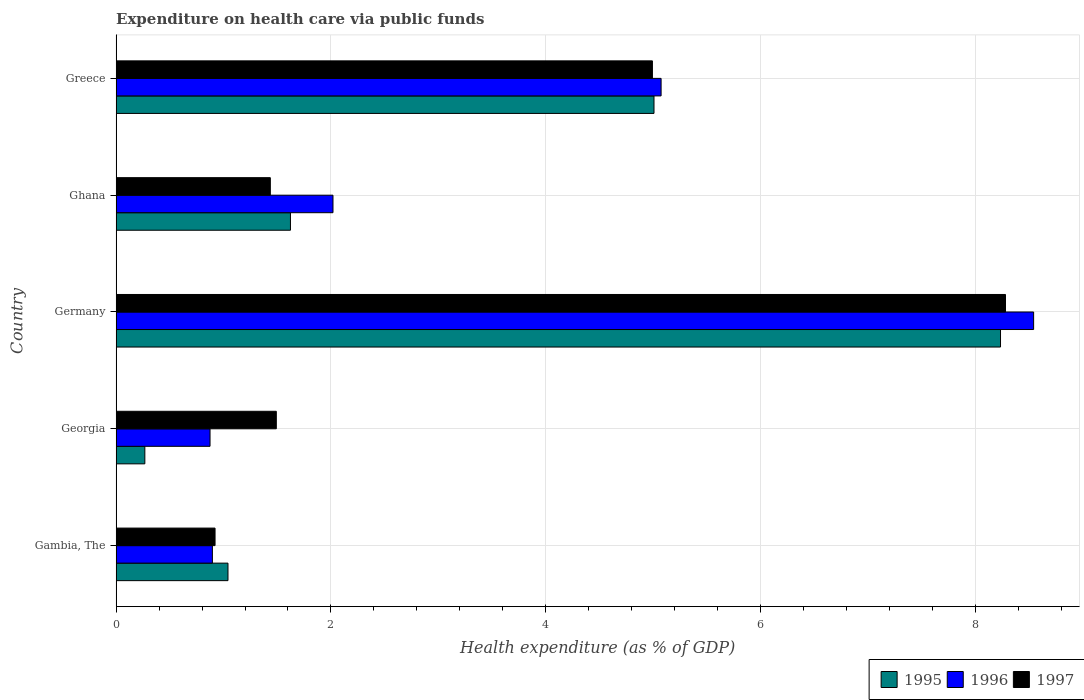How many groups of bars are there?
Your answer should be compact. 5. Are the number of bars per tick equal to the number of legend labels?
Provide a succinct answer. Yes. Are the number of bars on each tick of the Y-axis equal?
Provide a short and direct response. Yes. How many bars are there on the 3rd tick from the bottom?
Keep it short and to the point. 3. What is the label of the 5th group of bars from the top?
Offer a very short reply. Gambia, The. What is the expenditure made on health care in 1995 in Georgia?
Keep it short and to the point. 0.27. Across all countries, what is the maximum expenditure made on health care in 1995?
Offer a very short reply. 8.23. Across all countries, what is the minimum expenditure made on health care in 1996?
Your response must be concise. 0.87. In which country was the expenditure made on health care in 1995 maximum?
Offer a terse response. Germany. In which country was the expenditure made on health care in 1996 minimum?
Keep it short and to the point. Georgia. What is the total expenditure made on health care in 1995 in the graph?
Your answer should be compact. 16.17. What is the difference between the expenditure made on health care in 1995 in Gambia, The and that in Georgia?
Give a very brief answer. 0.77. What is the difference between the expenditure made on health care in 1995 in Greece and the expenditure made on health care in 1996 in Germany?
Give a very brief answer. -3.53. What is the average expenditure made on health care in 1997 per country?
Offer a terse response. 3.42. What is the difference between the expenditure made on health care in 1995 and expenditure made on health care in 1997 in Germany?
Ensure brevity in your answer.  -0.05. What is the ratio of the expenditure made on health care in 1997 in Gambia, The to that in Germany?
Your response must be concise. 0.11. Is the expenditure made on health care in 1995 in Ghana less than that in Greece?
Your answer should be very brief. Yes. Is the difference between the expenditure made on health care in 1995 in Georgia and Greece greater than the difference between the expenditure made on health care in 1997 in Georgia and Greece?
Your response must be concise. No. What is the difference between the highest and the second highest expenditure made on health care in 1996?
Give a very brief answer. 3.47. What is the difference between the highest and the lowest expenditure made on health care in 1996?
Offer a very short reply. 7.67. Is the sum of the expenditure made on health care in 1997 in Georgia and Ghana greater than the maximum expenditure made on health care in 1995 across all countries?
Ensure brevity in your answer.  No. What does the 2nd bar from the top in Germany represents?
Provide a succinct answer. 1996. What does the 1st bar from the bottom in Ghana represents?
Your answer should be compact. 1995. Are all the bars in the graph horizontal?
Your response must be concise. Yes. How many countries are there in the graph?
Your response must be concise. 5. Are the values on the major ticks of X-axis written in scientific E-notation?
Offer a very short reply. No. Does the graph contain any zero values?
Provide a succinct answer. No. What is the title of the graph?
Give a very brief answer. Expenditure on health care via public funds. What is the label or title of the X-axis?
Provide a short and direct response. Health expenditure (as % of GDP). What is the Health expenditure (as % of GDP) of 1995 in Gambia, The?
Keep it short and to the point. 1.04. What is the Health expenditure (as % of GDP) in 1996 in Gambia, The?
Ensure brevity in your answer.  0.9. What is the Health expenditure (as % of GDP) in 1997 in Gambia, The?
Give a very brief answer. 0.92. What is the Health expenditure (as % of GDP) in 1995 in Georgia?
Ensure brevity in your answer.  0.27. What is the Health expenditure (as % of GDP) in 1996 in Georgia?
Provide a short and direct response. 0.87. What is the Health expenditure (as % of GDP) in 1997 in Georgia?
Give a very brief answer. 1.49. What is the Health expenditure (as % of GDP) of 1995 in Germany?
Your response must be concise. 8.23. What is the Health expenditure (as % of GDP) in 1996 in Germany?
Your answer should be compact. 8.54. What is the Health expenditure (as % of GDP) in 1997 in Germany?
Offer a very short reply. 8.28. What is the Health expenditure (as % of GDP) of 1995 in Ghana?
Provide a short and direct response. 1.62. What is the Health expenditure (as % of GDP) in 1996 in Ghana?
Offer a terse response. 2.02. What is the Health expenditure (as % of GDP) of 1997 in Ghana?
Make the answer very short. 1.44. What is the Health expenditure (as % of GDP) of 1995 in Greece?
Offer a very short reply. 5.01. What is the Health expenditure (as % of GDP) in 1996 in Greece?
Your answer should be very brief. 5.07. What is the Health expenditure (as % of GDP) of 1997 in Greece?
Ensure brevity in your answer.  4.99. Across all countries, what is the maximum Health expenditure (as % of GDP) in 1995?
Make the answer very short. 8.23. Across all countries, what is the maximum Health expenditure (as % of GDP) in 1996?
Ensure brevity in your answer.  8.54. Across all countries, what is the maximum Health expenditure (as % of GDP) in 1997?
Offer a very short reply. 8.28. Across all countries, what is the minimum Health expenditure (as % of GDP) of 1995?
Make the answer very short. 0.27. Across all countries, what is the minimum Health expenditure (as % of GDP) of 1996?
Give a very brief answer. 0.87. Across all countries, what is the minimum Health expenditure (as % of GDP) of 1997?
Offer a very short reply. 0.92. What is the total Health expenditure (as % of GDP) in 1995 in the graph?
Offer a very short reply. 16.17. What is the total Health expenditure (as % of GDP) of 1996 in the graph?
Provide a succinct answer. 17.4. What is the total Health expenditure (as % of GDP) of 1997 in the graph?
Provide a short and direct response. 17.12. What is the difference between the Health expenditure (as % of GDP) of 1995 in Gambia, The and that in Georgia?
Your answer should be compact. 0.77. What is the difference between the Health expenditure (as % of GDP) of 1996 in Gambia, The and that in Georgia?
Keep it short and to the point. 0.02. What is the difference between the Health expenditure (as % of GDP) in 1997 in Gambia, The and that in Georgia?
Your answer should be very brief. -0.57. What is the difference between the Health expenditure (as % of GDP) in 1995 in Gambia, The and that in Germany?
Provide a short and direct response. -7.19. What is the difference between the Health expenditure (as % of GDP) in 1996 in Gambia, The and that in Germany?
Offer a very short reply. -7.65. What is the difference between the Health expenditure (as % of GDP) of 1997 in Gambia, The and that in Germany?
Your response must be concise. -7.36. What is the difference between the Health expenditure (as % of GDP) of 1995 in Gambia, The and that in Ghana?
Offer a very short reply. -0.58. What is the difference between the Health expenditure (as % of GDP) of 1996 in Gambia, The and that in Ghana?
Give a very brief answer. -1.12. What is the difference between the Health expenditure (as % of GDP) of 1997 in Gambia, The and that in Ghana?
Provide a short and direct response. -0.51. What is the difference between the Health expenditure (as % of GDP) in 1995 in Gambia, The and that in Greece?
Ensure brevity in your answer.  -3.97. What is the difference between the Health expenditure (as % of GDP) in 1996 in Gambia, The and that in Greece?
Keep it short and to the point. -4.18. What is the difference between the Health expenditure (as % of GDP) in 1997 in Gambia, The and that in Greece?
Give a very brief answer. -4.07. What is the difference between the Health expenditure (as % of GDP) in 1995 in Georgia and that in Germany?
Make the answer very short. -7.97. What is the difference between the Health expenditure (as % of GDP) of 1996 in Georgia and that in Germany?
Your answer should be very brief. -7.67. What is the difference between the Health expenditure (as % of GDP) of 1997 in Georgia and that in Germany?
Your answer should be compact. -6.79. What is the difference between the Health expenditure (as % of GDP) of 1995 in Georgia and that in Ghana?
Your response must be concise. -1.36. What is the difference between the Health expenditure (as % of GDP) of 1996 in Georgia and that in Ghana?
Keep it short and to the point. -1.14. What is the difference between the Health expenditure (as % of GDP) in 1997 in Georgia and that in Ghana?
Your response must be concise. 0.06. What is the difference between the Health expenditure (as % of GDP) in 1995 in Georgia and that in Greece?
Provide a short and direct response. -4.74. What is the difference between the Health expenditure (as % of GDP) of 1996 in Georgia and that in Greece?
Provide a succinct answer. -4.2. What is the difference between the Health expenditure (as % of GDP) in 1997 in Georgia and that in Greece?
Your answer should be compact. -3.5. What is the difference between the Health expenditure (as % of GDP) in 1995 in Germany and that in Ghana?
Provide a short and direct response. 6.61. What is the difference between the Health expenditure (as % of GDP) in 1996 in Germany and that in Ghana?
Offer a very short reply. 6.52. What is the difference between the Health expenditure (as % of GDP) in 1997 in Germany and that in Ghana?
Provide a short and direct response. 6.84. What is the difference between the Health expenditure (as % of GDP) of 1995 in Germany and that in Greece?
Ensure brevity in your answer.  3.23. What is the difference between the Health expenditure (as % of GDP) in 1996 in Germany and that in Greece?
Offer a very short reply. 3.47. What is the difference between the Health expenditure (as % of GDP) in 1997 in Germany and that in Greece?
Offer a terse response. 3.29. What is the difference between the Health expenditure (as % of GDP) of 1995 in Ghana and that in Greece?
Offer a very short reply. -3.38. What is the difference between the Health expenditure (as % of GDP) in 1996 in Ghana and that in Greece?
Ensure brevity in your answer.  -3.05. What is the difference between the Health expenditure (as % of GDP) of 1997 in Ghana and that in Greece?
Your answer should be compact. -3.56. What is the difference between the Health expenditure (as % of GDP) in 1995 in Gambia, The and the Health expenditure (as % of GDP) in 1996 in Georgia?
Give a very brief answer. 0.17. What is the difference between the Health expenditure (as % of GDP) of 1995 in Gambia, The and the Health expenditure (as % of GDP) of 1997 in Georgia?
Provide a succinct answer. -0.45. What is the difference between the Health expenditure (as % of GDP) of 1996 in Gambia, The and the Health expenditure (as % of GDP) of 1997 in Georgia?
Offer a terse response. -0.6. What is the difference between the Health expenditure (as % of GDP) of 1995 in Gambia, The and the Health expenditure (as % of GDP) of 1996 in Germany?
Your answer should be compact. -7.5. What is the difference between the Health expenditure (as % of GDP) of 1995 in Gambia, The and the Health expenditure (as % of GDP) of 1997 in Germany?
Provide a short and direct response. -7.24. What is the difference between the Health expenditure (as % of GDP) in 1996 in Gambia, The and the Health expenditure (as % of GDP) in 1997 in Germany?
Make the answer very short. -7.38. What is the difference between the Health expenditure (as % of GDP) of 1995 in Gambia, The and the Health expenditure (as % of GDP) of 1996 in Ghana?
Offer a very short reply. -0.98. What is the difference between the Health expenditure (as % of GDP) in 1995 in Gambia, The and the Health expenditure (as % of GDP) in 1997 in Ghana?
Offer a very short reply. -0.39. What is the difference between the Health expenditure (as % of GDP) of 1996 in Gambia, The and the Health expenditure (as % of GDP) of 1997 in Ghana?
Offer a very short reply. -0.54. What is the difference between the Health expenditure (as % of GDP) of 1995 in Gambia, The and the Health expenditure (as % of GDP) of 1996 in Greece?
Make the answer very short. -4.03. What is the difference between the Health expenditure (as % of GDP) in 1995 in Gambia, The and the Health expenditure (as % of GDP) in 1997 in Greece?
Ensure brevity in your answer.  -3.95. What is the difference between the Health expenditure (as % of GDP) of 1996 in Gambia, The and the Health expenditure (as % of GDP) of 1997 in Greece?
Make the answer very short. -4.1. What is the difference between the Health expenditure (as % of GDP) of 1995 in Georgia and the Health expenditure (as % of GDP) of 1996 in Germany?
Offer a terse response. -8.27. What is the difference between the Health expenditure (as % of GDP) in 1995 in Georgia and the Health expenditure (as % of GDP) in 1997 in Germany?
Keep it short and to the point. -8.01. What is the difference between the Health expenditure (as % of GDP) in 1996 in Georgia and the Health expenditure (as % of GDP) in 1997 in Germany?
Ensure brevity in your answer.  -7.41. What is the difference between the Health expenditure (as % of GDP) of 1995 in Georgia and the Health expenditure (as % of GDP) of 1996 in Ghana?
Your answer should be compact. -1.75. What is the difference between the Health expenditure (as % of GDP) in 1995 in Georgia and the Health expenditure (as % of GDP) in 1997 in Ghana?
Make the answer very short. -1.17. What is the difference between the Health expenditure (as % of GDP) in 1996 in Georgia and the Health expenditure (as % of GDP) in 1997 in Ghana?
Your answer should be very brief. -0.56. What is the difference between the Health expenditure (as % of GDP) of 1995 in Georgia and the Health expenditure (as % of GDP) of 1996 in Greece?
Offer a terse response. -4.81. What is the difference between the Health expenditure (as % of GDP) in 1995 in Georgia and the Health expenditure (as % of GDP) in 1997 in Greece?
Make the answer very short. -4.73. What is the difference between the Health expenditure (as % of GDP) in 1996 in Georgia and the Health expenditure (as % of GDP) in 1997 in Greece?
Make the answer very short. -4.12. What is the difference between the Health expenditure (as % of GDP) in 1995 in Germany and the Health expenditure (as % of GDP) in 1996 in Ghana?
Make the answer very short. 6.21. What is the difference between the Health expenditure (as % of GDP) of 1995 in Germany and the Health expenditure (as % of GDP) of 1997 in Ghana?
Keep it short and to the point. 6.8. What is the difference between the Health expenditure (as % of GDP) in 1996 in Germany and the Health expenditure (as % of GDP) in 1997 in Ghana?
Make the answer very short. 7.11. What is the difference between the Health expenditure (as % of GDP) of 1995 in Germany and the Health expenditure (as % of GDP) of 1996 in Greece?
Give a very brief answer. 3.16. What is the difference between the Health expenditure (as % of GDP) of 1995 in Germany and the Health expenditure (as % of GDP) of 1997 in Greece?
Make the answer very short. 3.24. What is the difference between the Health expenditure (as % of GDP) in 1996 in Germany and the Health expenditure (as % of GDP) in 1997 in Greece?
Ensure brevity in your answer.  3.55. What is the difference between the Health expenditure (as % of GDP) in 1995 in Ghana and the Health expenditure (as % of GDP) in 1996 in Greece?
Your response must be concise. -3.45. What is the difference between the Health expenditure (as % of GDP) in 1995 in Ghana and the Health expenditure (as % of GDP) in 1997 in Greece?
Your answer should be compact. -3.37. What is the difference between the Health expenditure (as % of GDP) of 1996 in Ghana and the Health expenditure (as % of GDP) of 1997 in Greece?
Give a very brief answer. -2.97. What is the average Health expenditure (as % of GDP) of 1995 per country?
Give a very brief answer. 3.23. What is the average Health expenditure (as % of GDP) in 1996 per country?
Your response must be concise. 3.48. What is the average Health expenditure (as % of GDP) in 1997 per country?
Provide a succinct answer. 3.42. What is the difference between the Health expenditure (as % of GDP) in 1995 and Health expenditure (as % of GDP) in 1996 in Gambia, The?
Your response must be concise. 0.15. What is the difference between the Health expenditure (as % of GDP) of 1995 and Health expenditure (as % of GDP) of 1997 in Gambia, The?
Keep it short and to the point. 0.12. What is the difference between the Health expenditure (as % of GDP) in 1996 and Health expenditure (as % of GDP) in 1997 in Gambia, The?
Your response must be concise. -0.02. What is the difference between the Health expenditure (as % of GDP) of 1995 and Health expenditure (as % of GDP) of 1996 in Georgia?
Give a very brief answer. -0.61. What is the difference between the Health expenditure (as % of GDP) in 1995 and Health expenditure (as % of GDP) in 1997 in Georgia?
Provide a short and direct response. -1.22. What is the difference between the Health expenditure (as % of GDP) in 1996 and Health expenditure (as % of GDP) in 1997 in Georgia?
Your response must be concise. -0.62. What is the difference between the Health expenditure (as % of GDP) in 1995 and Health expenditure (as % of GDP) in 1996 in Germany?
Make the answer very short. -0.31. What is the difference between the Health expenditure (as % of GDP) in 1995 and Health expenditure (as % of GDP) in 1997 in Germany?
Provide a short and direct response. -0.05. What is the difference between the Health expenditure (as % of GDP) in 1996 and Health expenditure (as % of GDP) in 1997 in Germany?
Give a very brief answer. 0.26. What is the difference between the Health expenditure (as % of GDP) in 1995 and Health expenditure (as % of GDP) in 1996 in Ghana?
Your answer should be compact. -0.4. What is the difference between the Health expenditure (as % of GDP) of 1995 and Health expenditure (as % of GDP) of 1997 in Ghana?
Your answer should be very brief. 0.19. What is the difference between the Health expenditure (as % of GDP) in 1996 and Health expenditure (as % of GDP) in 1997 in Ghana?
Your answer should be compact. 0.58. What is the difference between the Health expenditure (as % of GDP) of 1995 and Health expenditure (as % of GDP) of 1996 in Greece?
Your response must be concise. -0.07. What is the difference between the Health expenditure (as % of GDP) in 1995 and Health expenditure (as % of GDP) in 1997 in Greece?
Offer a very short reply. 0.01. What is the difference between the Health expenditure (as % of GDP) of 1996 and Health expenditure (as % of GDP) of 1997 in Greece?
Offer a terse response. 0.08. What is the ratio of the Health expenditure (as % of GDP) in 1995 in Gambia, The to that in Georgia?
Provide a succinct answer. 3.9. What is the ratio of the Health expenditure (as % of GDP) of 1996 in Gambia, The to that in Georgia?
Offer a very short reply. 1.03. What is the ratio of the Health expenditure (as % of GDP) in 1997 in Gambia, The to that in Georgia?
Your answer should be very brief. 0.62. What is the ratio of the Health expenditure (as % of GDP) in 1995 in Gambia, The to that in Germany?
Your response must be concise. 0.13. What is the ratio of the Health expenditure (as % of GDP) in 1996 in Gambia, The to that in Germany?
Your response must be concise. 0.1. What is the ratio of the Health expenditure (as % of GDP) of 1997 in Gambia, The to that in Germany?
Keep it short and to the point. 0.11. What is the ratio of the Health expenditure (as % of GDP) in 1995 in Gambia, The to that in Ghana?
Your response must be concise. 0.64. What is the ratio of the Health expenditure (as % of GDP) in 1996 in Gambia, The to that in Ghana?
Make the answer very short. 0.44. What is the ratio of the Health expenditure (as % of GDP) of 1997 in Gambia, The to that in Ghana?
Your answer should be very brief. 0.64. What is the ratio of the Health expenditure (as % of GDP) in 1995 in Gambia, The to that in Greece?
Your answer should be very brief. 0.21. What is the ratio of the Health expenditure (as % of GDP) in 1996 in Gambia, The to that in Greece?
Keep it short and to the point. 0.18. What is the ratio of the Health expenditure (as % of GDP) of 1997 in Gambia, The to that in Greece?
Offer a terse response. 0.18. What is the ratio of the Health expenditure (as % of GDP) in 1995 in Georgia to that in Germany?
Your response must be concise. 0.03. What is the ratio of the Health expenditure (as % of GDP) in 1996 in Georgia to that in Germany?
Give a very brief answer. 0.1. What is the ratio of the Health expenditure (as % of GDP) in 1997 in Georgia to that in Germany?
Offer a very short reply. 0.18. What is the ratio of the Health expenditure (as % of GDP) of 1995 in Georgia to that in Ghana?
Your response must be concise. 0.16. What is the ratio of the Health expenditure (as % of GDP) in 1996 in Georgia to that in Ghana?
Your answer should be compact. 0.43. What is the ratio of the Health expenditure (as % of GDP) in 1997 in Georgia to that in Ghana?
Keep it short and to the point. 1.04. What is the ratio of the Health expenditure (as % of GDP) in 1995 in Georgia to that in Greece?
Keep it short and to the point. 0.05. What is the ratio of the Health expenditure (as % of GDP) in 1996 in Georgia to that in Greece?
Keep it short and to the point. 0.17. What is the ratio of the Health expenditure (as % of GDP) of 1997 in Georgia to that in Greece?
Offer a very short reply. 0.3. What is the ratio of the Health expenditure (as % of GDP) of 1995 in Germany to that in Ghana?
Your answer should be compact. 5.07. What is the ratio of the Health expenditure (as % of GDP) in 1996 in Germany to that in Ghana?
Your response must be concise. 4.23. What is the ratio of the Health expenditure (as % of GDP) in 1997 in Germany to that in Ghana?
Your response must be concise. 5.77. What is the ratio of the Health expenditure (as % of GDP) of 1995 in Germany to that in Greece?
Provide a succinct answer. 1.64. What is the ratio of the Health expenditure (as % of GDP) in 1996 in Germany to that in Greece?
Your answer should be compact. 1.68. What is the ratio of the Health expenditure (as % of GDP) of 1997 in Germany to that in Greece?
Make the answer very short. 1.66. What is the ratio of the Health expenditure (as % of GDP) of 1995 in Ghana to that in Greece?
Give a very brief answer. 0.32. What is the ratio of the Health expenditure (as % of GDP) of 1996 in Ghana to that in Greece?
Ensure brevity in your answer.  0.4. What is the ratio of the Health expenditure (as % of GDP) in 1997 in Ghana to that in Greece?
Make the answer very short. 0.29. What is the difference between the highest and the second highest Health expenditure (as % of GDP) of 1995?
Ensure brevity in your answer.  3.23. What is the difference between the highest and the second highest Health expenditure (as % of GDP) in 1996?
Offer a very short reply. 3.47. What is the difference between the highest and the second highest Health expenditure (as % of GDP) of 1997?
Your answer should be very brief. 3.29. What is the difference between the highest and the lowest Health expenditure (as % of GDP) of 1995?
Your response must be concise. 7.97. What is the difference between the highest and the lowest Health expenditure (as % of GDP) in 1996?
Offer a very short reply. 7.67. What is the difference between the highest and the lowest Health expenditure (as % of GDP) of 1997?
Your response must be concise. 7.36. 